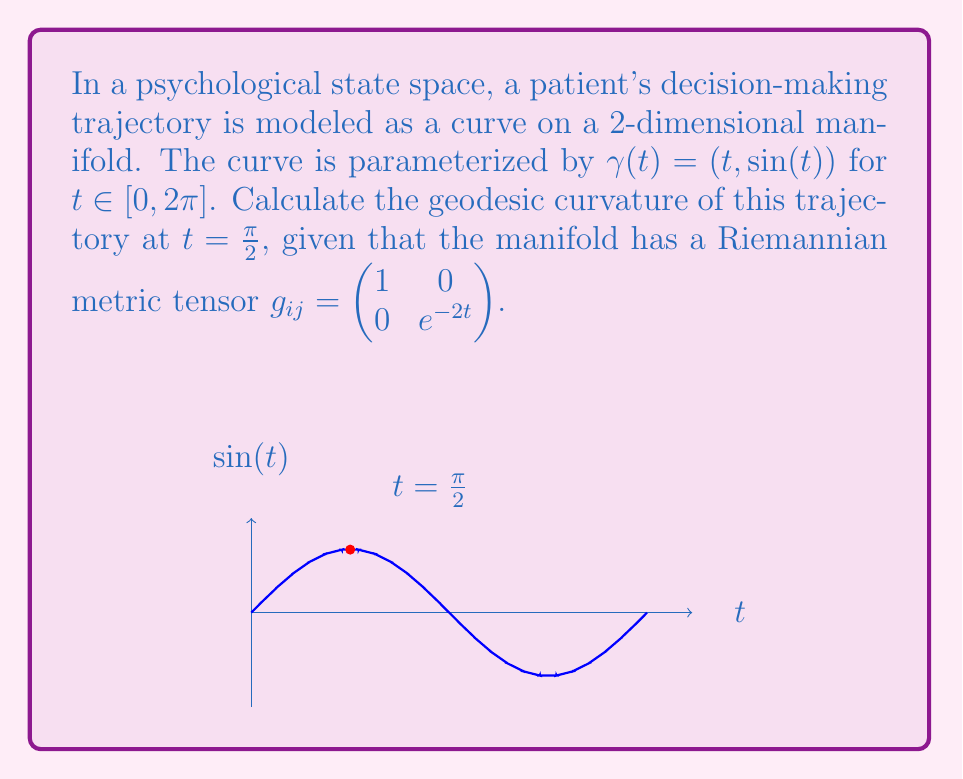Give your solution to this math problem. To calculate the geodesic curvature, we'll follow these steps:

1) The geodesic curvature is given by:

   $$\kappa_g = \frac{1}{\sqrt{g_{ij}\dot{\gamma}^i\dot{\gamma}^j}} \left( \frac{D^2\gamma^i}{dt^2} + \Gamma^i_{jk}\dot{\gamma}^j\dot{\gamma}^k \right) n_i$$

   where $n_i$ is the unit normal vector.

2) First, we need to calculate $\dot{\gamma}$ and $\ddot{\gamma}$:
   
   $\dot{\gamma} = (1, \cos(t))$
   $\ddot{\gamma} = (0, -\sin(t))$

3) The Christoffel symbols are:

   $\Gamma^1_{11} = \Gamma^1_{12} = \Gamma^1_{21} = \Gamma^2_{11} = 0$
   $\Gamma^2_{12} = \Gamma^2_{21} = -1$
   $\Gamma^2_{22} = 0$

4) Calculate $\frac{D^2\gamma^i}{dt^2} + \Gamma^i_{jk}\dot{\gamma}^j\dot{\gamma}^k$:

   For $i=1$: $0 + 0 = 0$
   For $i=2$: $-\sin(t) + (-1)(1)(\cos(t)) - (-1)(\cos(t))(1) = -\sin(t)$

5) The unit normal vector is:

   $n = \frac{1}{\sqrt{g_{11}g_{22}}} (-\dot{\gamma}^2, \dot{\gamma}^1) = \frac{1}{\sqrt{e^{-2t}}} (-\cos(t), 1)$

6) Calculate $\sqrt{g_{ij}\dot{\gamma}^i\dot{\gamma}^j}$:

   $\sqrt{1 \cdot 1^2 + e^{-2t} \cdot \cos^2(t)} = \sqrt{1 + e^{-2t}\cos^2(t)}$

7) Putting it all together at $t = \frac{\pi}{2}$:

   $$\kappa_g = \frac{1}{\sqrt{1 + e^{-\pi}\cos^2(\frac{\pi}{2})}} \cdot (0 \cdot \frac{-0}{\sqrt{e^{-\pi}}} + (-1) \cdot \frac{1}{\sqrt{e^{-\pi}}}) = -\frac{1}{\sqrt{e^{\pi}}}$$
Answer: $-\frac{1}{\sqrt{e^{\pi}}}$ 